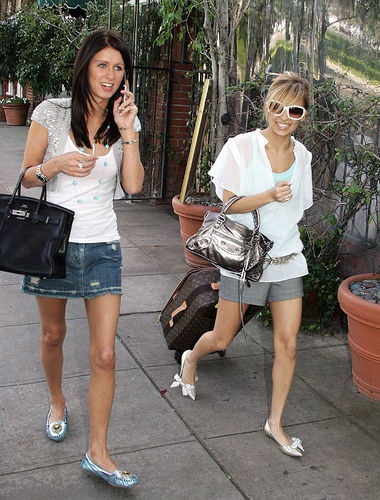Describe the objects in this image and their specific colors. I can see people in black, lightgray, gray, and tan tones, people in black, lightgray, gray, and tan tones, potted plant in black, gray, and brown tones, potted plant in black, gray, brown, and darkgray tones, and handbag in black, gray, and darkgray tones in this image. 